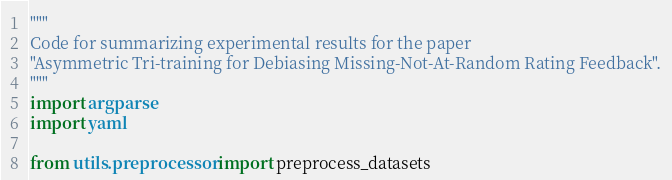<code> <loc_0><loc_0><loc_500><loc_500><_Python_>"""
Code for summarizing experimental results for the paper
"Asymmetric Tri-training for Debiasing Missing-Not-At-Random Rating Feedback".
"""
import argparse
import yaml

from utils.preprocessor import preprocess_datasets</code> 